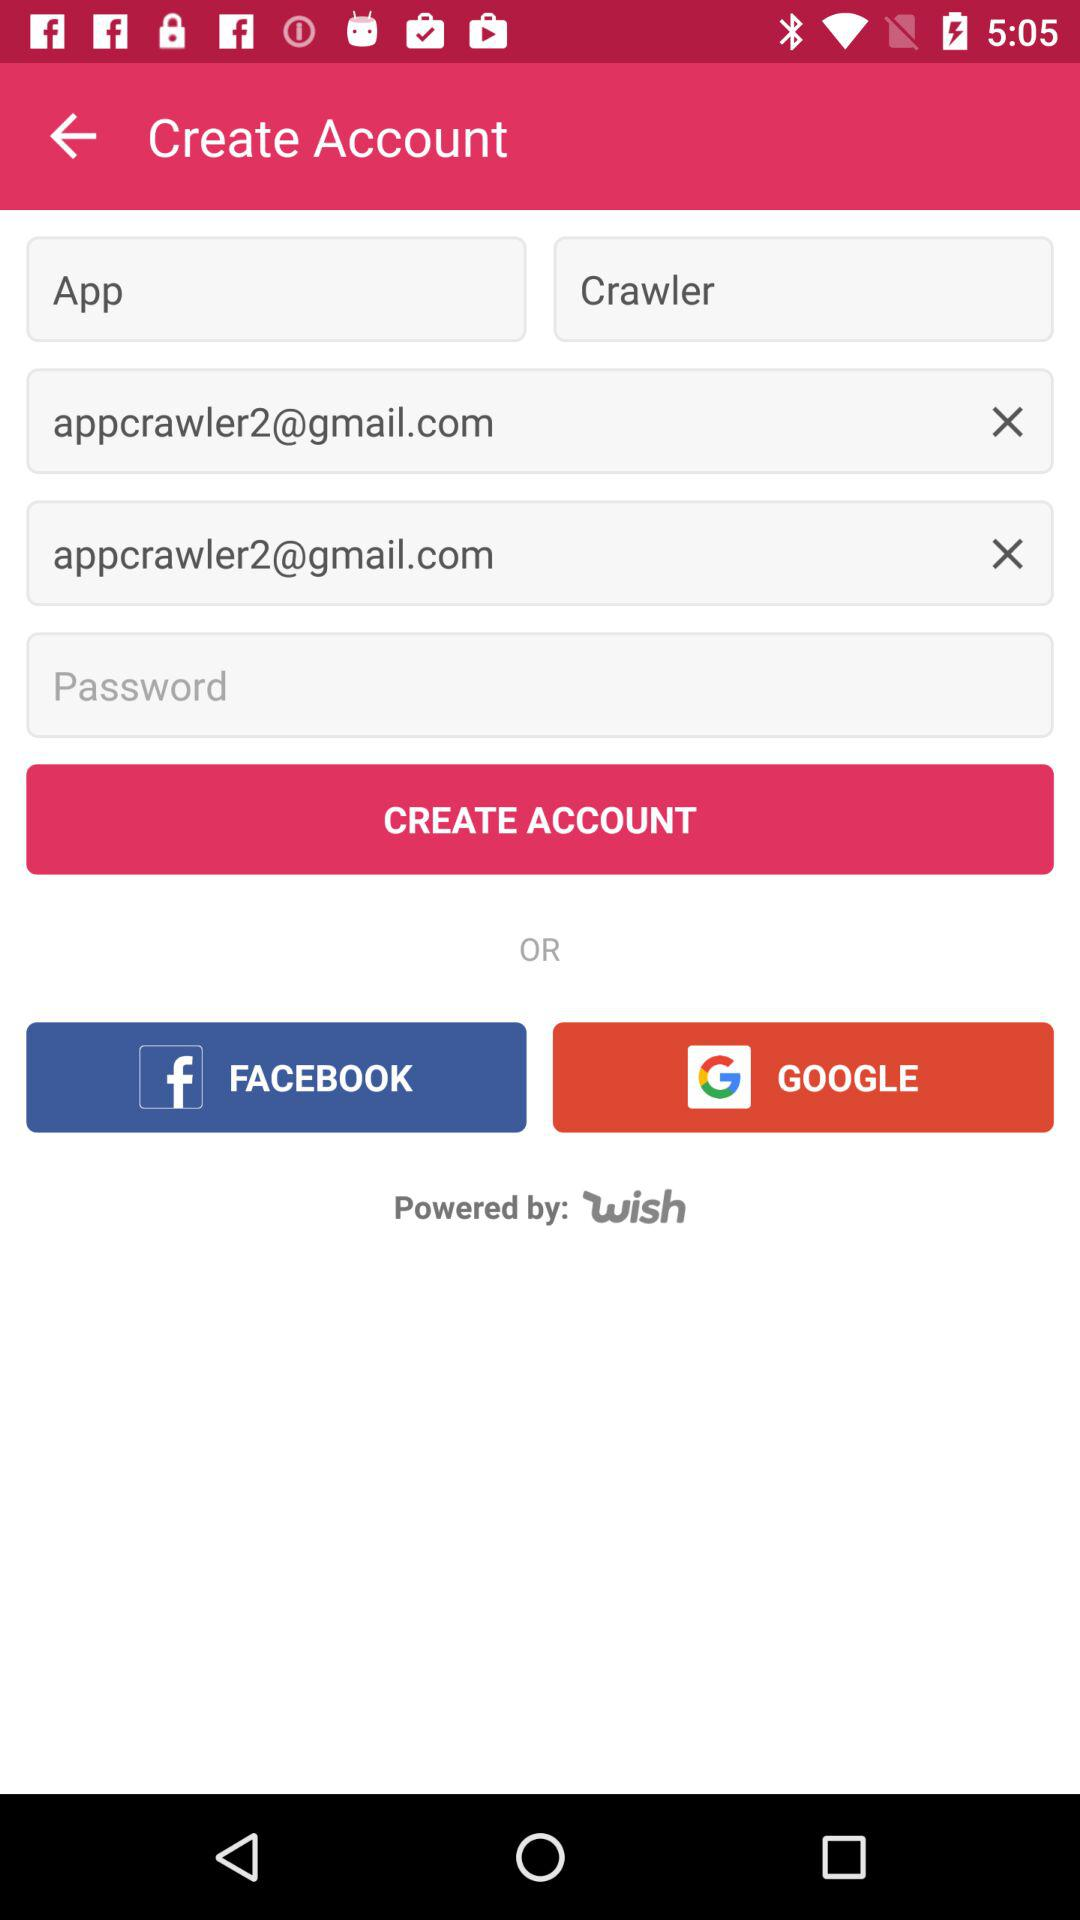What is the first name? The first name is App. 